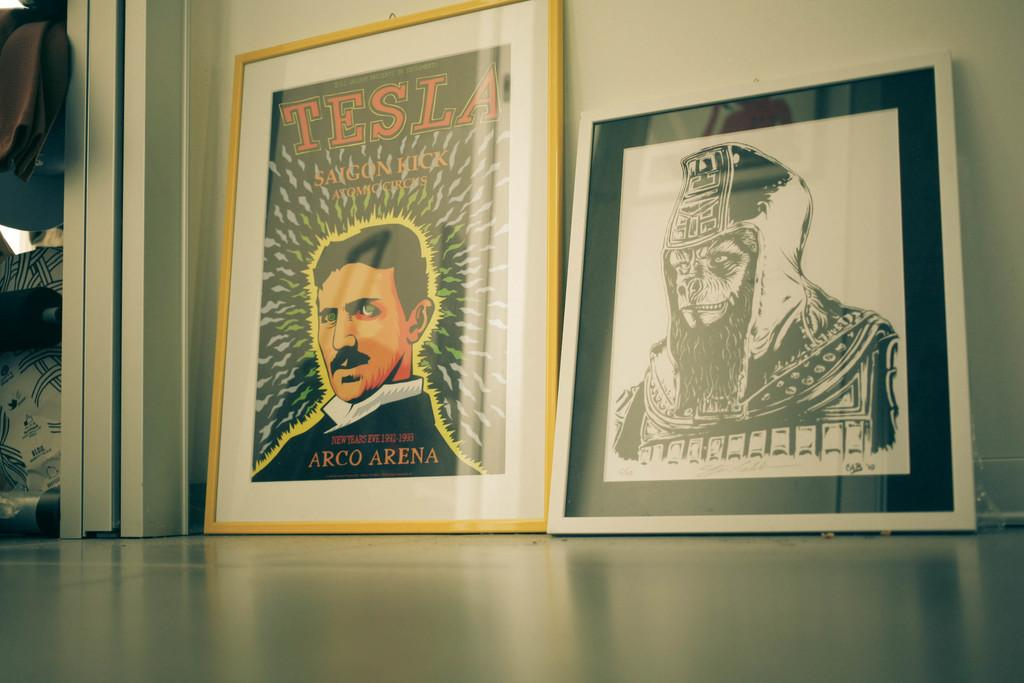Provide a one-sentence caption for the provided image. Two picture against a wall one of which has a man's face on it with "Tesla" above him. 